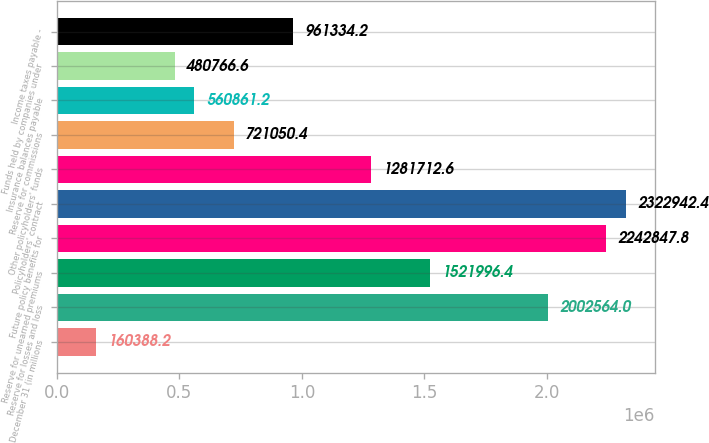<chart> <loc_0><loc_0><loc_500><loc_500><bar_chart><fcel>December 31 (in millions<fcel>Reserve for losses and loss<fcel>Reserve for unearned premiums<fcel>Future policy benefits for<fcel>Policyholders' contract<fcel>Other policyholders' funds<fcel>Reserve for commissions<fcel>Insurance balances payable<fcel>Funds held by companies under<fcel>Income taxes payable -<nl><fcel>160388<fcel>2.00256e+06<fcel>1.522e+06<fcel>2.24285e+06<fcel>2.32294e+06<fcel>1.28171e+06<fcel>721050<fcel>560861<fcel>480767<fcel>961334<nl></chart> 